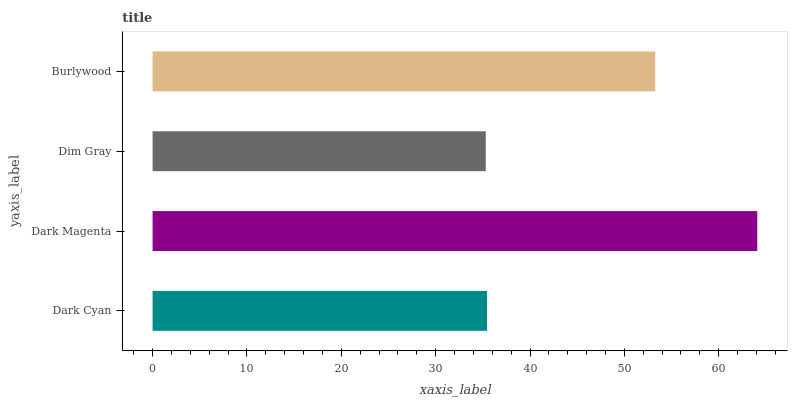Is Dim Gray the minimum?
Answer yes or no. Yes. Is Dark Magenta the maximum?
Answer yes or no. Yes. Is Dark Magenta the minimum?
Answer yes or no. No. Is Dim Gray the maximum?
Answer yes or no. No. Is Dark Magenta greater than Dim Gray?
Answer yes or no. Yes. Is Dim Gray less than Dark Magenta?
Answer yes or no. Yes. Is Dim Gray greater than Dark Magenta?
Answer yes or no. No. Is Dark Magenta less than Dim Gray?
Answer yes or no. No. Is Burlywood the high median?
Answer yes or no. Yes. Is Dark Cyan the low median?
Answer yes or no. Yes. Is Dark Cyan the high median?
Answer yes or no. No. Is Dim Gray the low median?
Answer yes or no. No. 